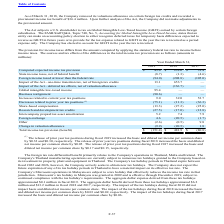According to Microchip Technology's financial document, What does the foreign tax rate differential benefit primarily relate to? the Company's operations in Thailand, Malta and Ireland.. The document states: "tax rate differential benefit primarily relates to the Company's operations in Thailand, Malta and Ireland. The..." Also, What was the State income taxes, net of federal benefit in 2019? According to the financial document, (8.7) (in millions). The relevant text states: "State income taxes, net of federal benefit (8.7) (1.3) (4.6)..." Also, Which years does the table provide information for The sources and tax effects of the differences in the total income tax provision? The document contains multiple relevant values: 2019, 2018, 2017. From the document: "2019 2018 2017 2019 2018 2017 2019 2018 2017..." Also, How many years did Intercompany prepaid tax asset amortization exceed $7 million? Counting the relevant items in the document: 2018, 2017, I find 2 instances. The key data points involved are: 2017, 2018. Also, can you calculate: What was the change in the Computed expected income tax provision between 2017 and 2018? Based on the calculation: 232.6-31.4, the result is 201.2 (in millions). This is based on the information: "Computed expected income tax provision $ 43.0 $ 232.6 $ 31.4 ed expected income tax provision $ 43.0 $ 232.6 $ 31.4..." The key data points involved are: 232.6, 31.4. Also, can you calculate: What was the percentage change in the Total income tax provision (benefit) between 2018 and 2019? To answer this question, I need to perform calculations using the financial data. The calculation is: (-151.4-481.9)/481.9, which equals -131.42 (percentage). This is based on the information: "Total income tax provision (benefit) $ (151.4) $ 481.9 $ (80.8) Total income tax provision (benefit) $ (151.4) $ 481.9 $ (80.8)..." The key data points involved are: 151.4, 481.9. 